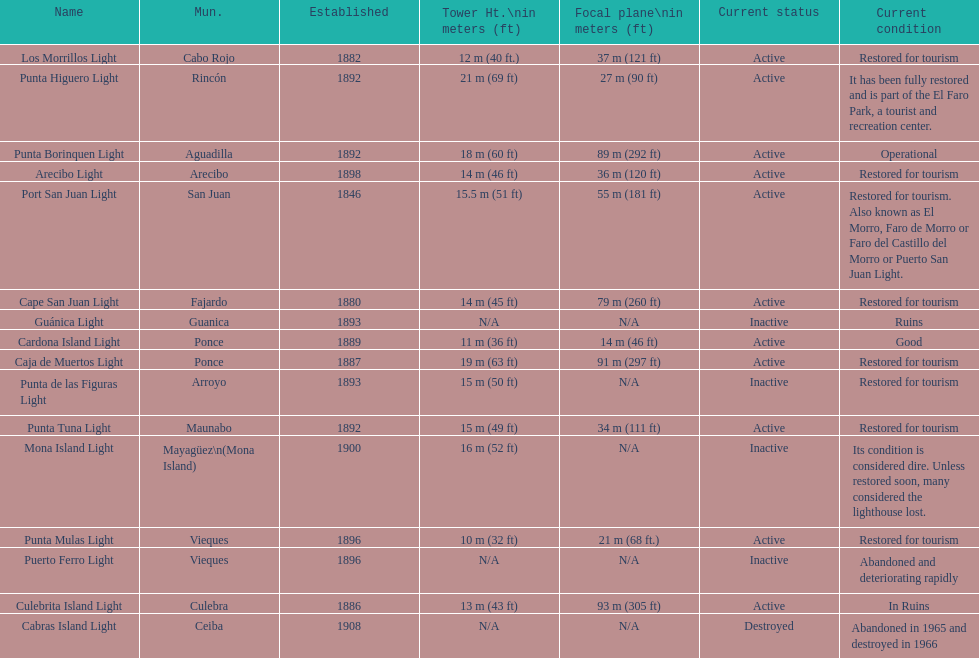How many establishments are restored for tourism? 9. 